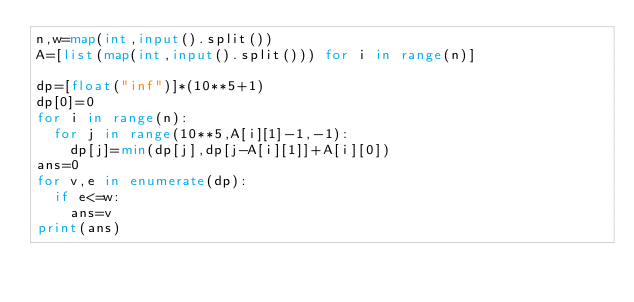Convert code to text. <code><loc_0><loc_0><loc_500><loc_500><_Python_>n,w=map(int,input().split())
A=[list(map(int,input().split())) for i in range(n)]

dp=[float("inf")]*(10**5+1)
dp[0]=0
for i in range(n):
  for j in range(10**5,A[i][1]-1,-1):
    dp[j]=min(dp[j],dp[j-A[i][1]]+A[i][0])
ans=0
for v,e in enumerate(dp):
  if e<=w:
    ans=v
print(ans)</code> 